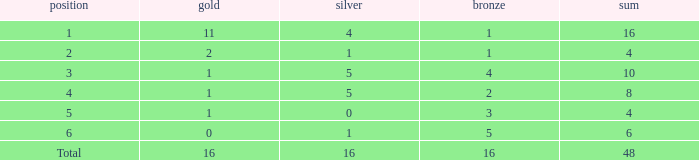What is the total gold that has bronze less than 2, a silver of 1 and total more than 4? None. 